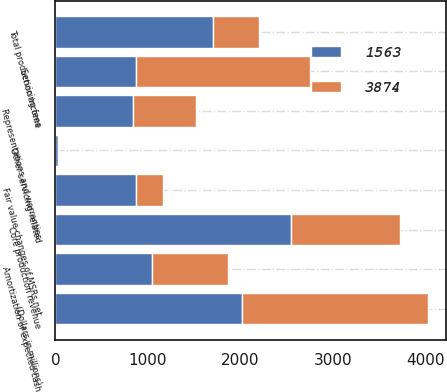Convert chart to OTSL. <chart><loc_0><loc_0><loc_500><loc_500><stacked_bar_chart><ecel><fcel>(Dollars in millions)<fcel>Core production revenue<fcel>Representations and warranties<fcel>Total production income<fcel>Servicing fees<fcel>Amortization of expected cash<fcel>Fair value changes of MSRs net<fcel>Other servicing-related<nl><fcel>3874<fcel>2014<fcel>1181<fcel>683<fcel>498<fcel>1884<fcel>818<fcel>294<fcel>8<nl><fcel>1563<fcel>2013<fcel>2543<fcel>840<fcel>1703<fcel>867<fcel>1043<fcel>867<fcel>28<nl></chart> 